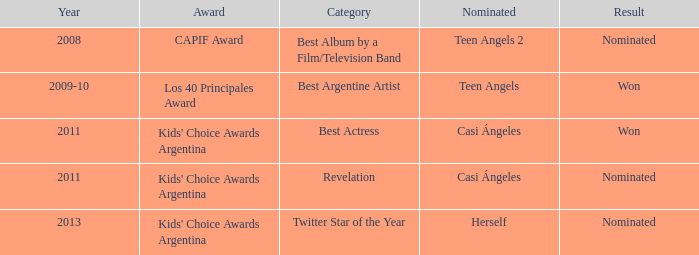In what group was herself nominated? Twitter Star of the Year. 